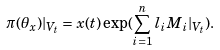Convert formula to latex. <formula><loc_0><loc_0><loc_500><loc_500>\pi ( \theta _ { x } ) | _ { V _ { t } } = x ( t ) \exp ( \sum _ { i = 1 } ^ { n } l _ { i } M _ { i } | _ { V _ { t } } ) .</formula> 